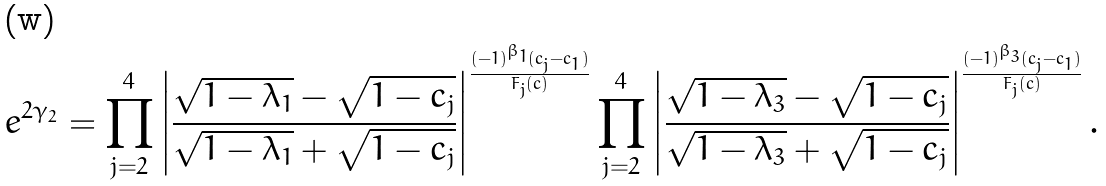<formula> <loc_0><loc_0><loc_500><loc_500>e ^ { 2 \gamma _ { 2 } } = \prod _ { j = 2 } ^ { 4 } \left | \frac { \sqrt { 1 - \lambda _ { 1 } } - \sqrt { 1 - c _ { j } } } { \sqrt { 1 - \lambda _ { 1 } } + \sqrt { 1 - c _ { j } } } \right | ^ { \frac { ( - 1 ) ^ { \beta _ { 1 } } ( c _ { j } - c _ { 1 } ) } { F _ { j } ( c ) } } \prod _ { j = 2 } ^ { 4 } \left | \frac { \sqrt { 1 - \lambda _ { 3 } } - \sqrt { 1 - c _ { j } } } { \sqrt { 1 - \lambda _ { 3 } } + \sqrt { 1 - c _ { j } } } \right | ^ { \frac { ( - 1 ) ^ { \beta _ { 3 } } ( c _ { j } - c _ { 1 } ) } { F _ { j } ( c ) } } .</formula> 